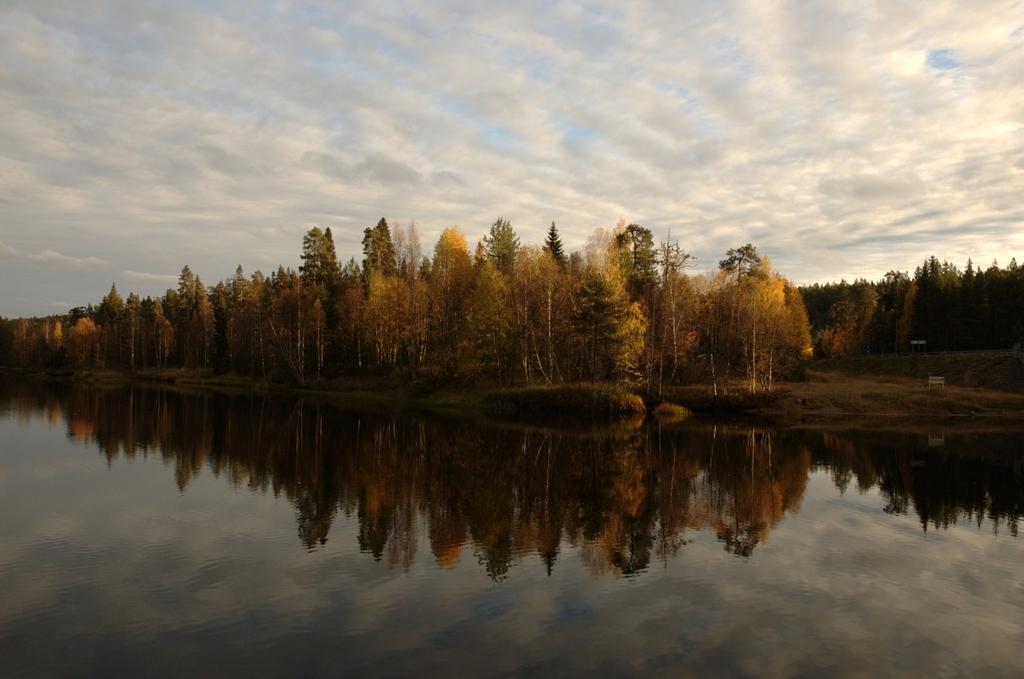Describe this image in one or two sentences. In the picture there is water, in the water we can see the reflection of trees, beside the water there are trees, there is a clear sky. 